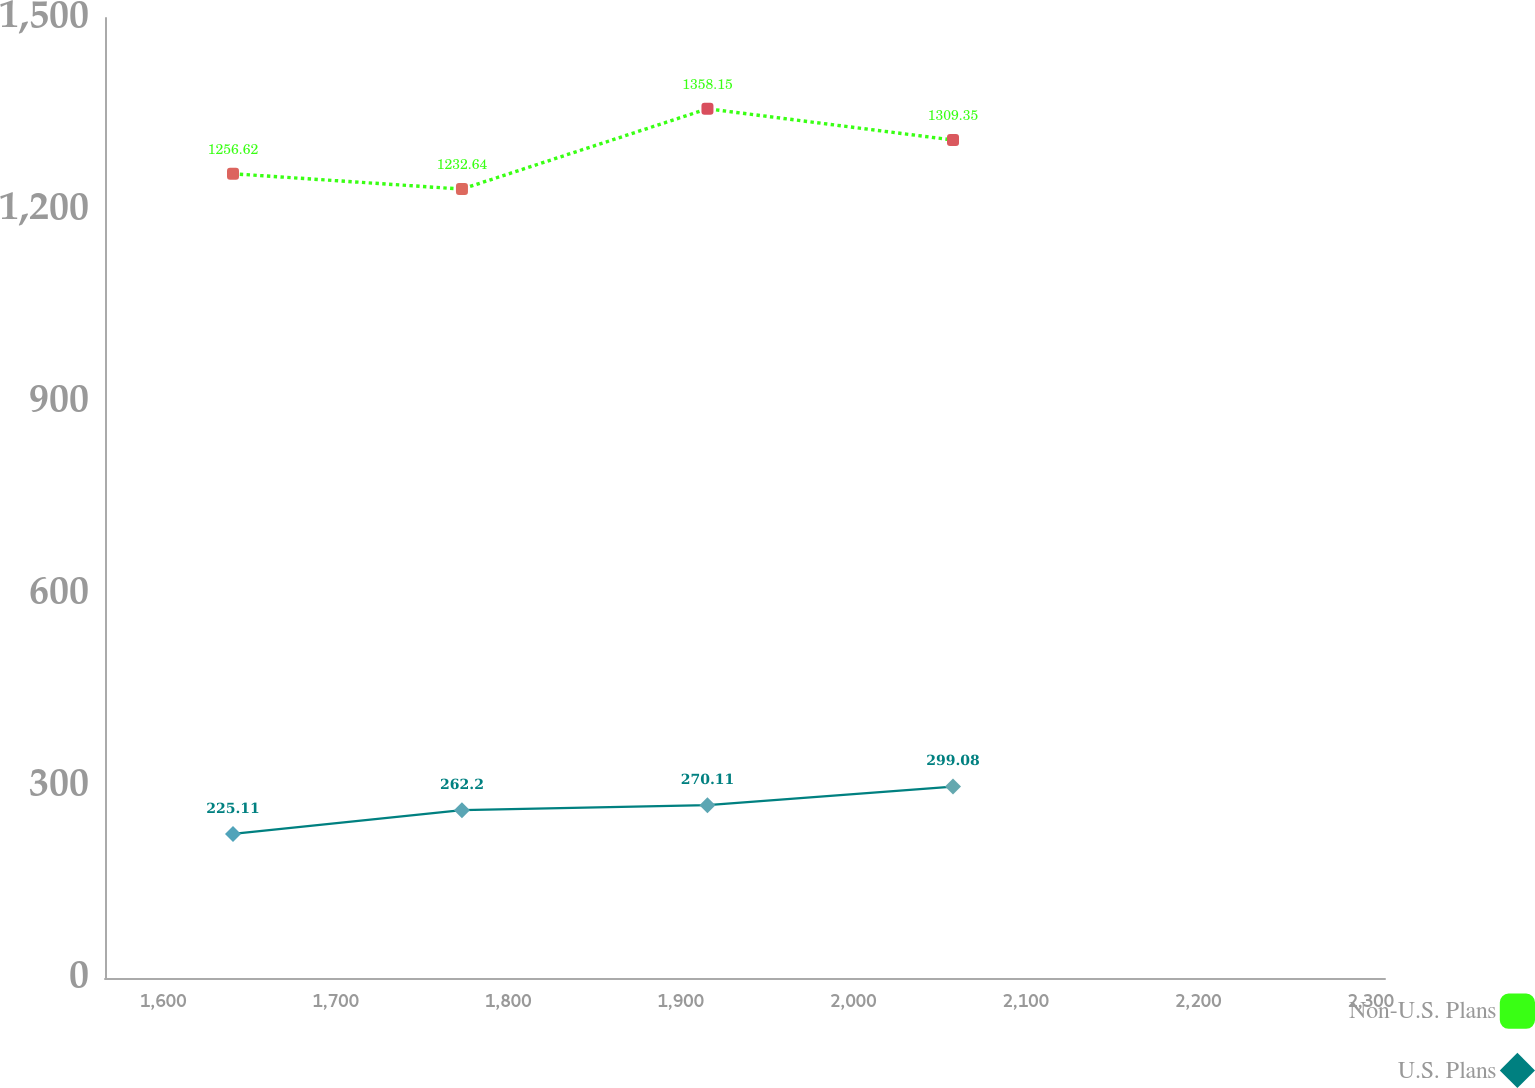Convert chart. <chart><loc_0><loc_0><loc_500><loc_500><line_chart><ecel><fcel>Non-U.S. Plans<fcel>U.S. Plans<nl><fcel>1640.43<fcel>1256.62<fcel>225.11<nl><fcel>1773.16<fcel>1232.64<fcel>262.2<nl><fcel>1915.48<fcel>1358.15<fcel>270.11<nl><fcel>2057.83<fcel>1309.35<fcel>299.08<nl><fcel>2382.47<fcel>1118.4<fcel>306.99<nl></chart> 